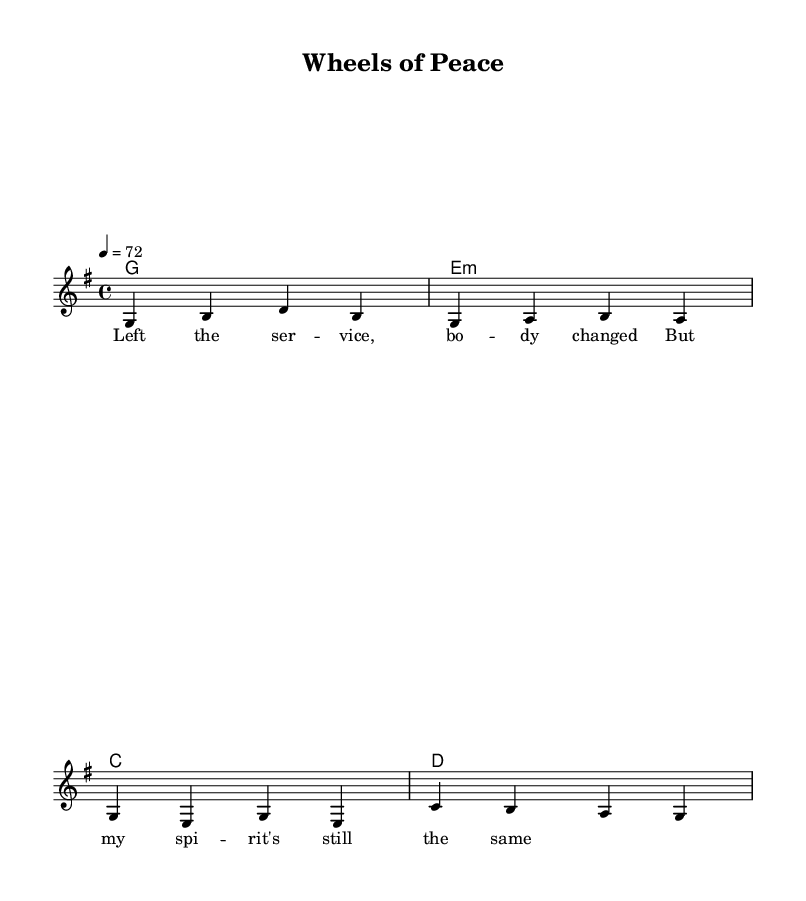What is the key signature of this music? The key signature is G major, which has one sharp (F#). It can be determined by looking at the key signature notation at the beginning of the staff.
Answer: G major What is the time signature of this music? The time signature is 4/4, indicated at the beginning of the sheet music. It means there are four beats in each measure and the quarter note receives one beat.
Answer: 4/4 What is the tempo marking for this piece? The tempo marking is "4 = 72," which shows that the quarter note should be played at a speed of 72 beats per minute. This is indicated above the staff.
Answer: 72 How many measures are in the melody line? The melody line consists of four measures, as seen by counting the vertical lines separating the phrases in the melody section.
Answer: 4 What is the chord progression used in this piece? The chord progression is G, E minor, C, D. This can be found in the chord mode section, which shows the chords written above the rhythm of the melody.
Answer: G, E minor, C, D Why might the lyrics be focused on finding peace after military service? The lyrics express themes of change and spiritual continuity, which could resonate with those transitioning from military life to civilian life, signaling a search for inner peace. This context is derived from the lyrics provided, which suggest a personal journey after service.
Answer: Finding peace 